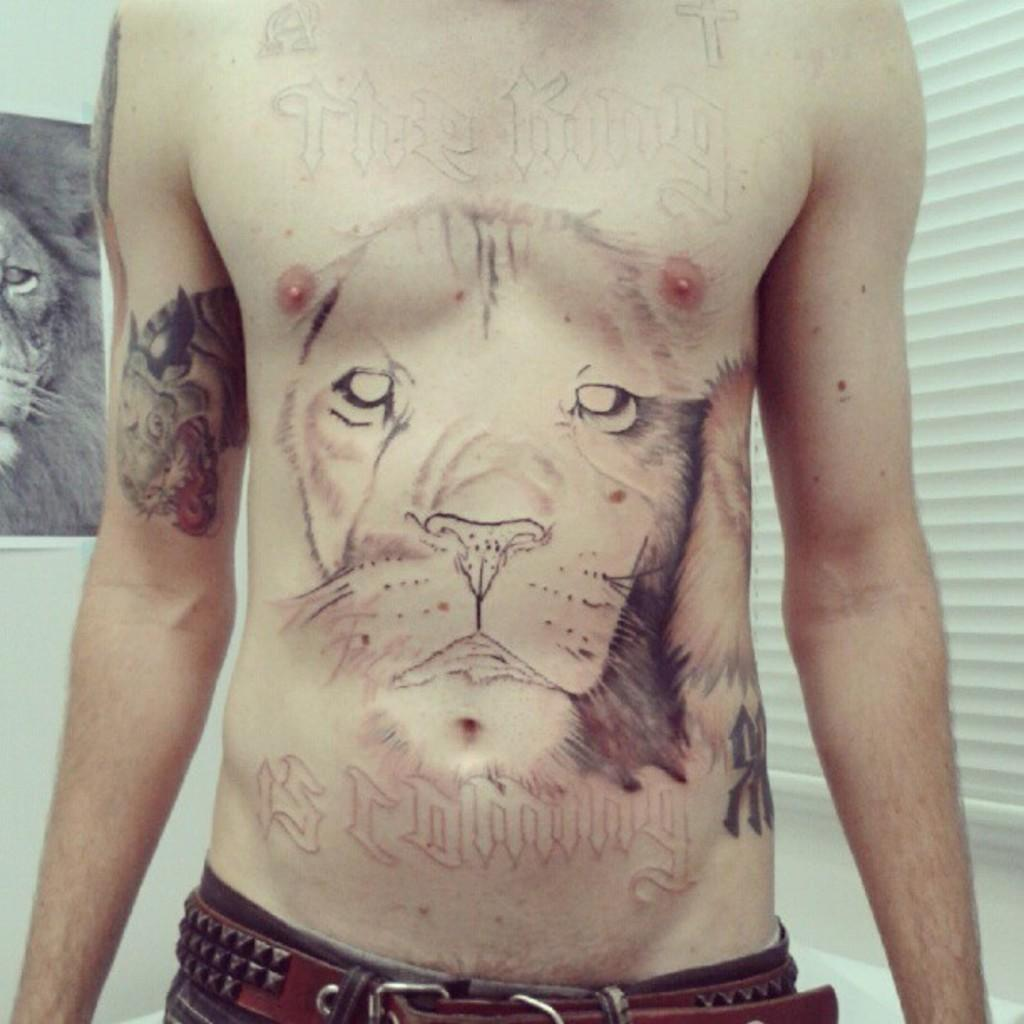What can be seen on the person's body in the image? There are tattoos on the person's body in the image. What is attached to the white wall in the image? There is a lion pamphlet attached to a white wall in the image. What type of cabbage is being used as a decoration in the image? There is no cabbage present in the image. How many tubs are visible in the image? There are no tubs visible in the image. 